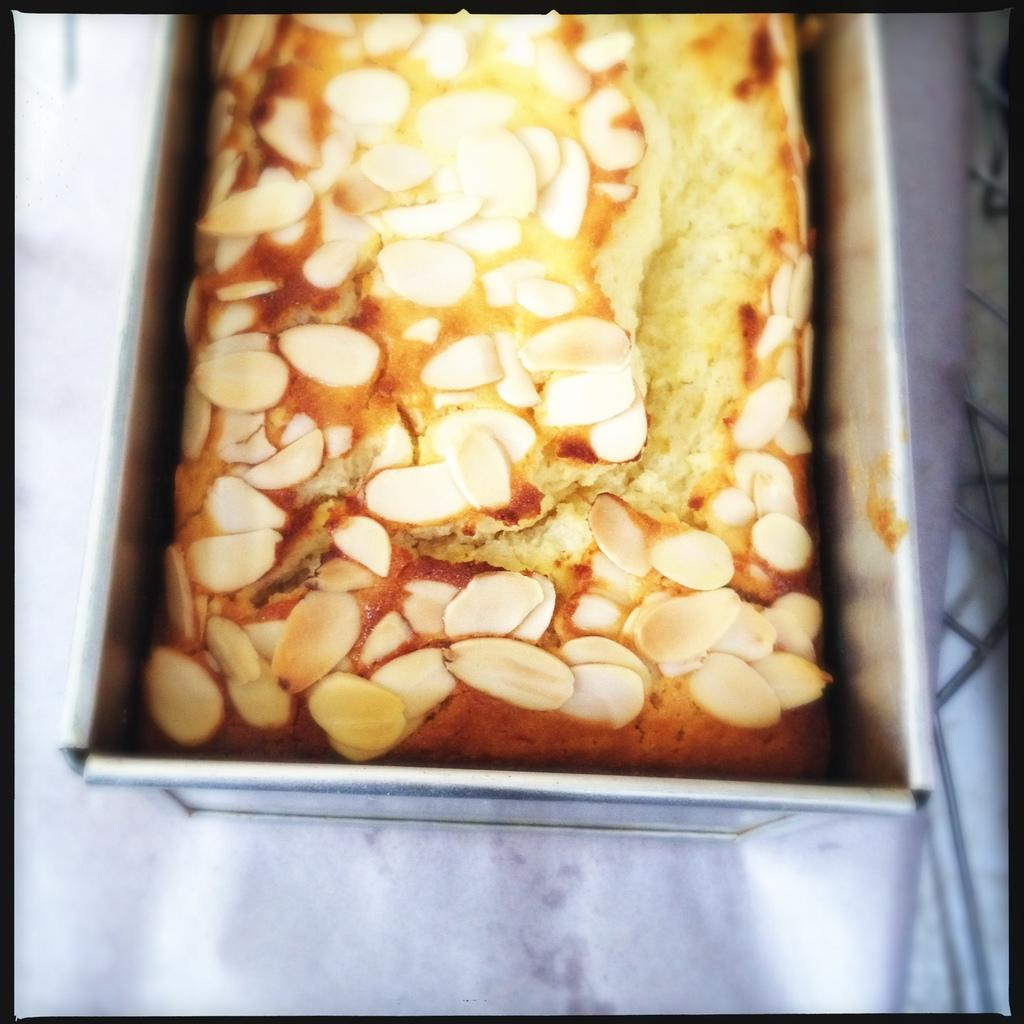What type of food can be seen in the image? The food in the image is in cream and brown color. What is the color of the box containing the food? The box containing the food is in silver color. On what surface is the box placed? The box is on a white surface. What type of polish is being applied to the food in the image? There is no polish being applied to the food in the image; it is simply food in cream and brown color. 